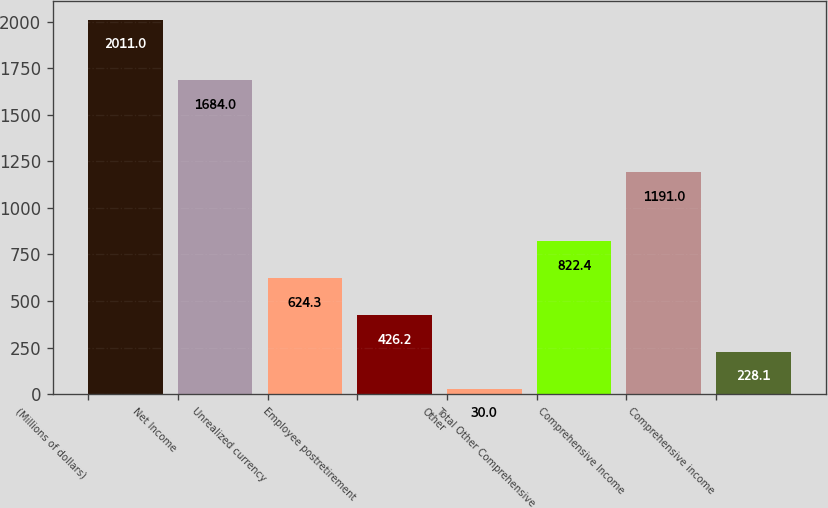<chart> <loc_0><loc_0><loc_500><loc_500><bar_chart><fcel>(Millions of dollars)<fcel>Net Income<fcel>Unrealized currency<fcel>Employee postretirement<fcel>Other<fcel>Total Other Comprehensive<fcel>Comprehensive Income<fcel>Comprehensive income<nl><fcel>2011<fcel>1684<fcel>624.3<fcel>426.2<fcel>30<fcel>822.4<fcel>1191<fcel>228.1<nl></chart> 